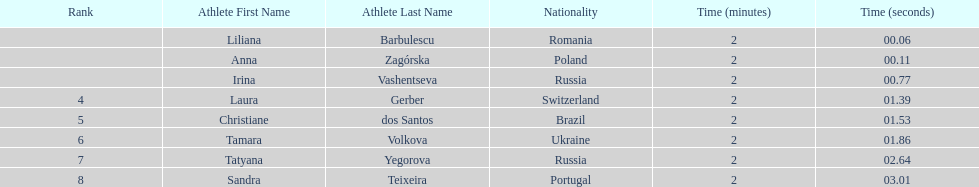Could you parse the entire table as a dict? {'header': ['Rank', 'Athlete First Name', 'Athlete Last Name', 'Nationality', 'Time (minutes)', 'Time (seconds)'], 'rows': [['', 'Liliana', 'Barbulescu', 'Romania', '2', '00.06'], ['', 'Anna', 'Zagórska', 'Poland', '2', '00.11'], ['', 'Irina', 'Vashentseva', 'Russia', '2', '00.77'], ['4', 'Laura', 'Gerber', 'Switzerland', '2', '01.39'], ['5', 'Christiane', 'dos Santos', 'Brazil', '2', '01.53'], ['6', 'Tamara', 'Volkova', 'Ukraine', '2', '01.86'], ['7', 'Tatyana', 'Yegorova', 'Russia', '2', '02.64'], ['8', 'Sandra', 'Teixeira', 'Portugal', '2', '03.01']]} The last runner crossed the finish line in 2:03.01. what was the previous time for the 7th runner? 2:02.64. 